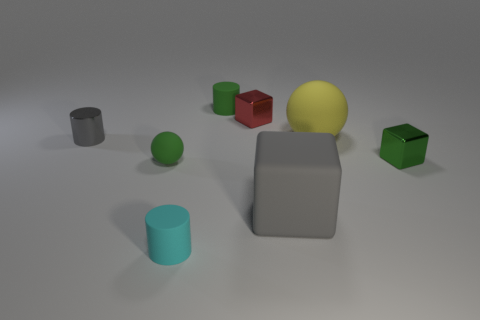There is a yellow object that is the same size as the gray block; what is its shape? sphere 